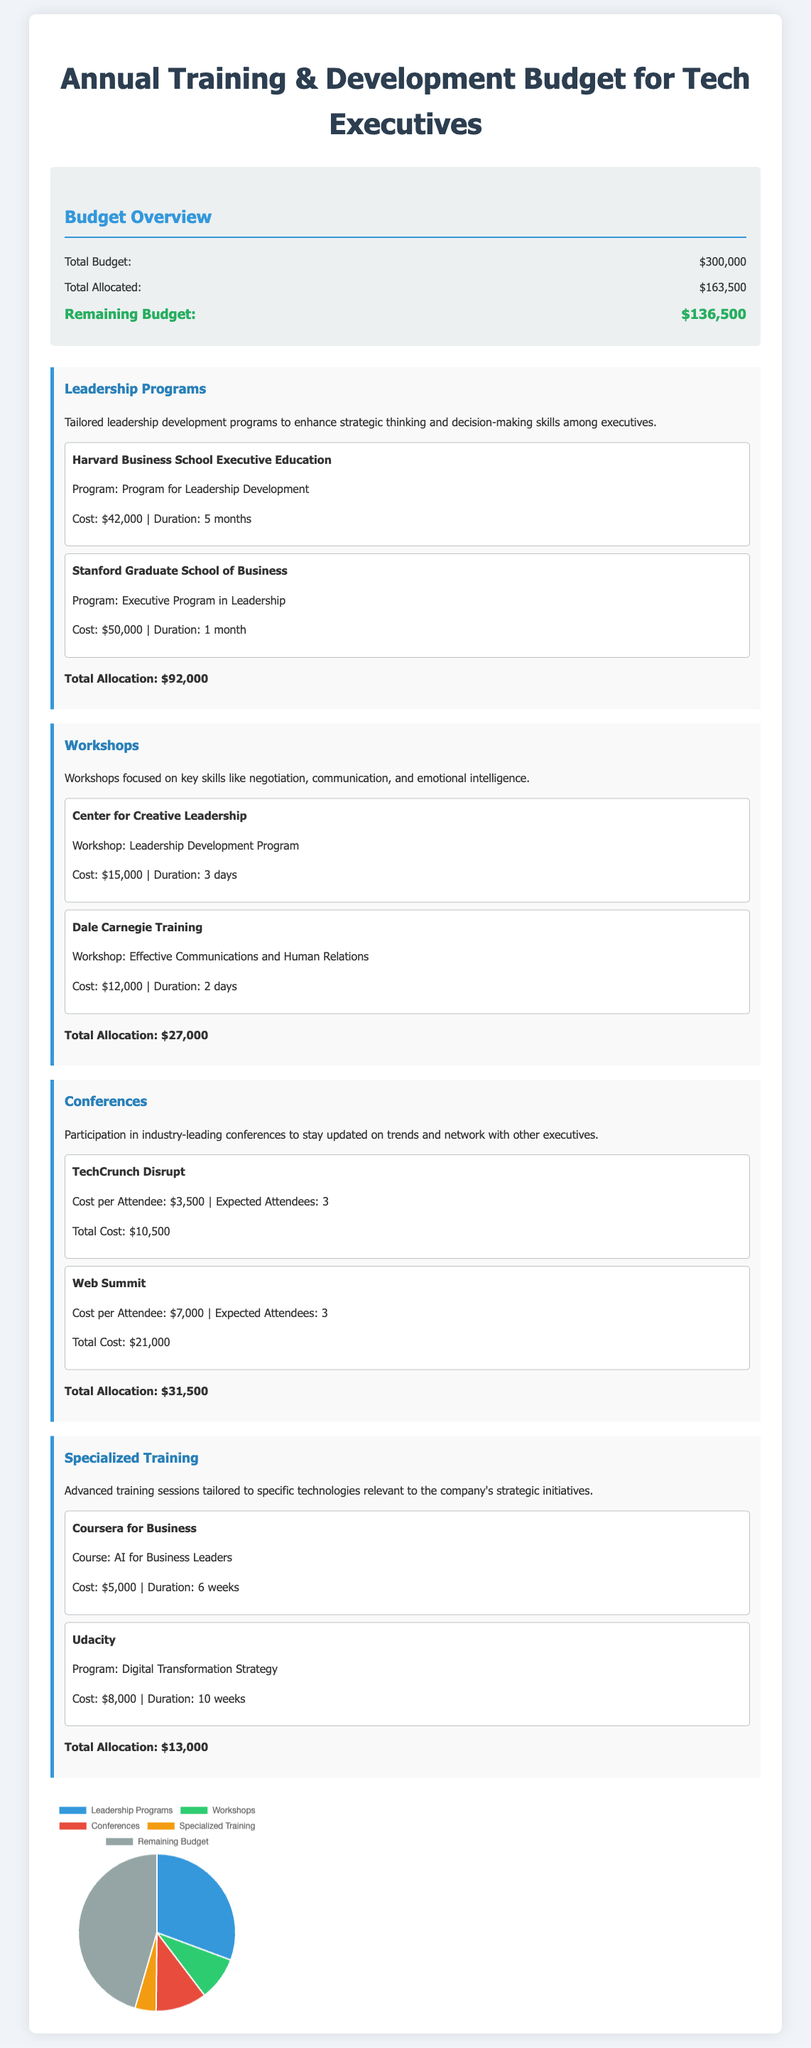what is the total budget? The total budget is stated explicitly in the document under the budget overview section.
Answer: $300,000 what is the total allocated amount? The total allocated amount is provided in the budget overview section, indicating the funds already allocated for training and development.
Answer: $163,500 how much is allocated for leadership programs? The total allocation for leadership programs includes the cost of all listed programs from the relevant section.
Answer: $92,000 who provides the Executive Program in Leadership? The document lists providers for different programs, clearly stating who offers the Executive Program in Leadership.
Answer: Stanford Graduate School of Business what is the total allocation for workshops? This value is calculated by summing the costs of the specified workshops in the document.
Answer: $27,000 how many attendees are expected for Web Summit? The document provides the cost per attendee and the expected number of attendees for the Web Summit, leading to this figure.
Answer: 3 what is the total cost of TechCrunch Disrupt? The total cost is mentioned beside the event details, encompassing all expected attendees and their costs.
Answer: $10,500 what is the remaining budget? The remaining budget is clearly stated in the budget overview section as the difference between the total budget and total allocated amount.
Answer: $136,500 which course is offered by Coursera for Business? The document specifies the course provided by Coursera for Business regarding training and development.
Answer: AI for Business Leaders 